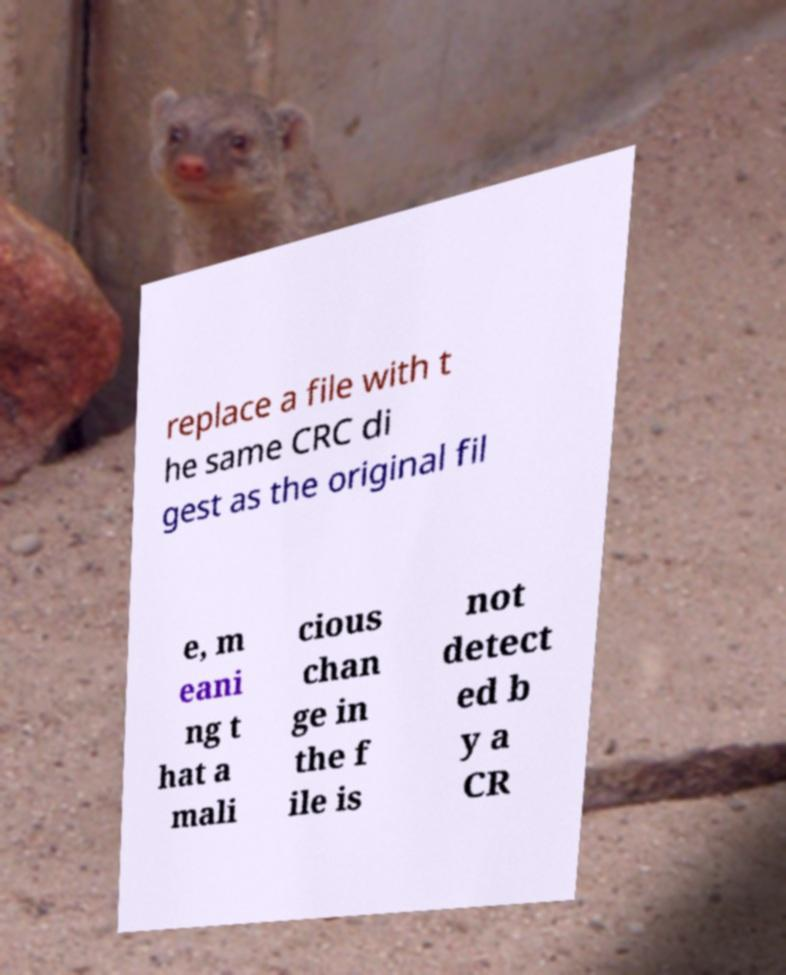Please identify and transcribe the text found in this image. replace a file with t he same CRC di gest as the original fil e, m eani ng t hat a mali cious chan ge in the f ile is not detect ed b y a CR 